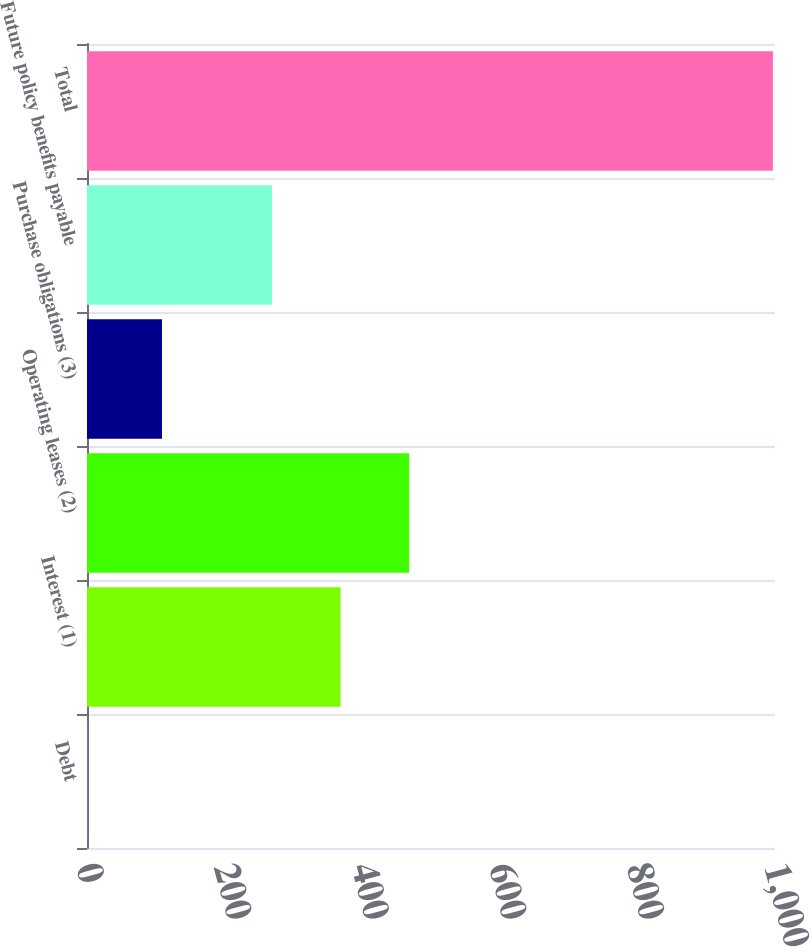<chart> <loc_0><loc_0><loc_500><loc_500><bar_chart><fcel>Debt<fcel>Interest (1)<fcel>Operating leases (2)<fcel>Purchase obligations (3)<fcel>Future policy benefits payable<fcel>Total<nl><fcel>1.05<fcel>368.6<fcel>468.2<fcel>109<fcel>269<fcel>997<nl></chart> 